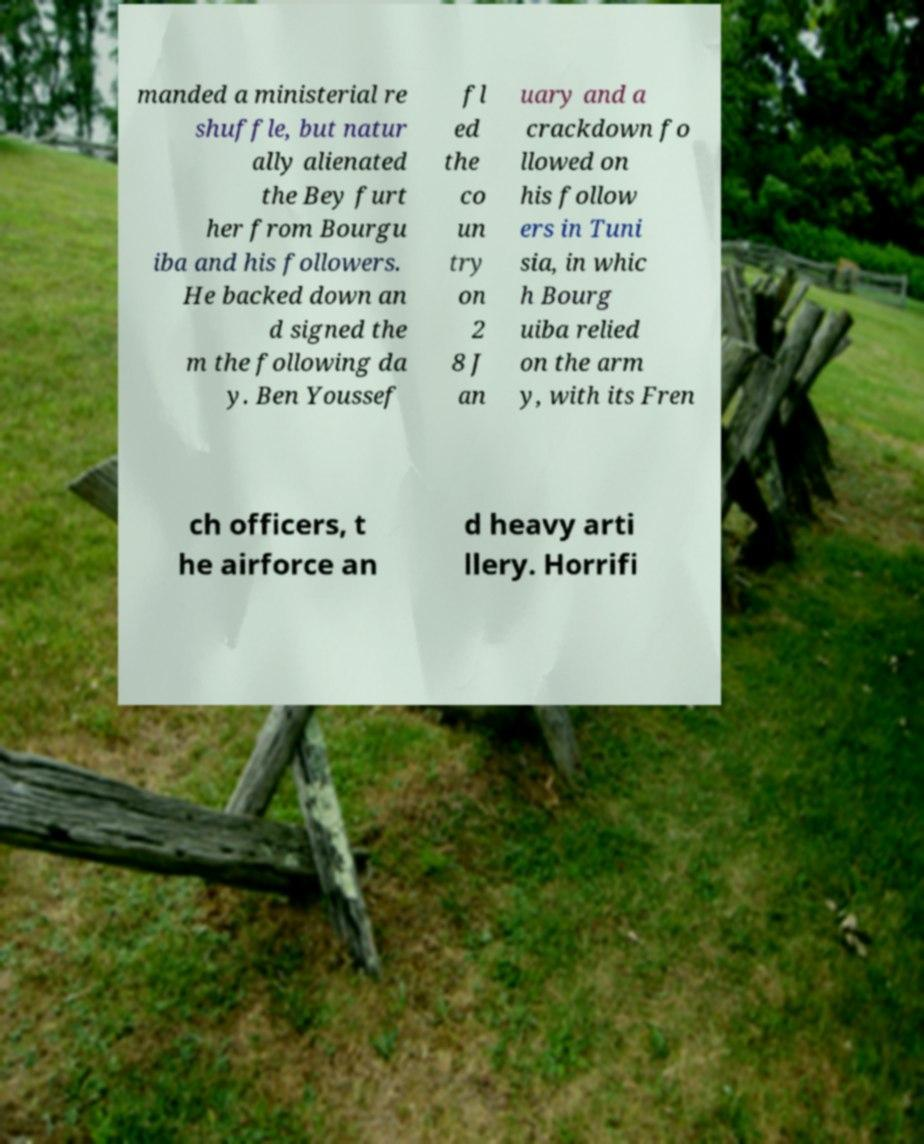Can you accurately transcribe the text from the provided image for me? manded a ministerial re shuffle, but natur ally alienated the Bey furt her from Bourgu iba and his followers. He backed down an d signed the m the following da y. Ben Youssef fl ed the co un try on 2 8 J an uary and a crackdown fo llowed on his follow ers in Tuni sia, in whic h Bourg uiba relied on the arm y, with its Fren ch officers, t he airforce an d heavy arti llery. Horrifi 